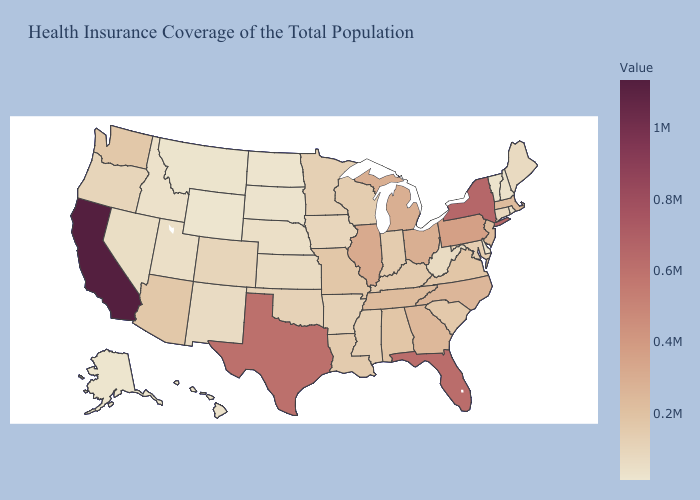Does Idaho have a higher value than Kentucky?
Be succinct. No. Among the states that border Kansas , does Oklahoma have the lowest value?
Answer briefly. No. Does the map have missing data?
Quick response, please. No. 